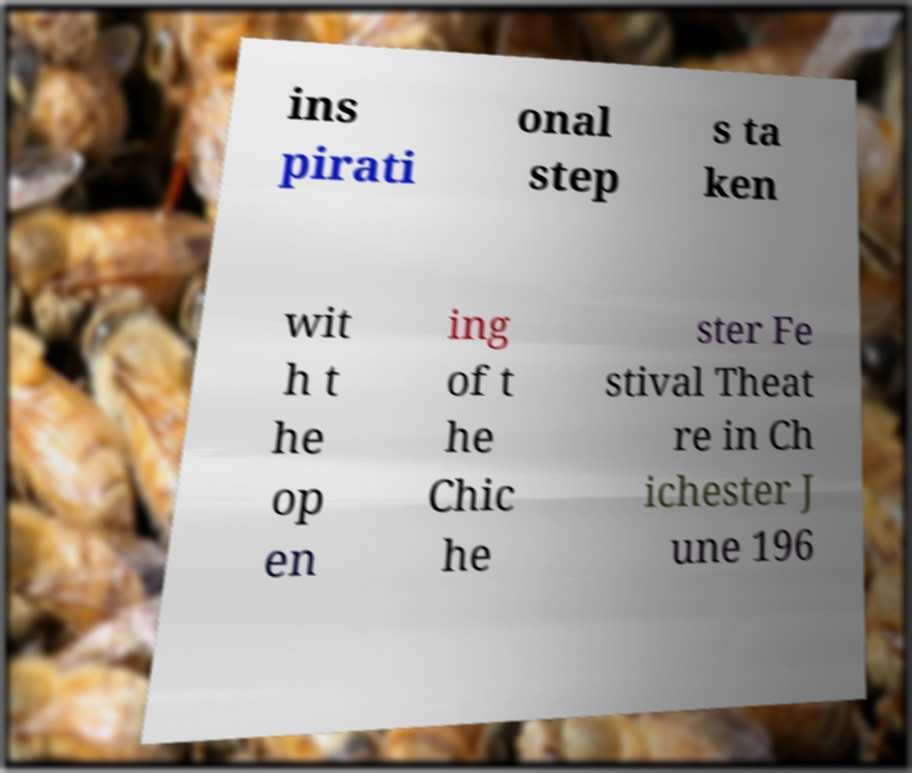For documentation purposes, I need the text within this image transcribed. Could you provide that? ins pirati onal step s ta ken wit h t he op en ing of t he Chic he ster Fe stival Theat re in Ch ichester J une 196 